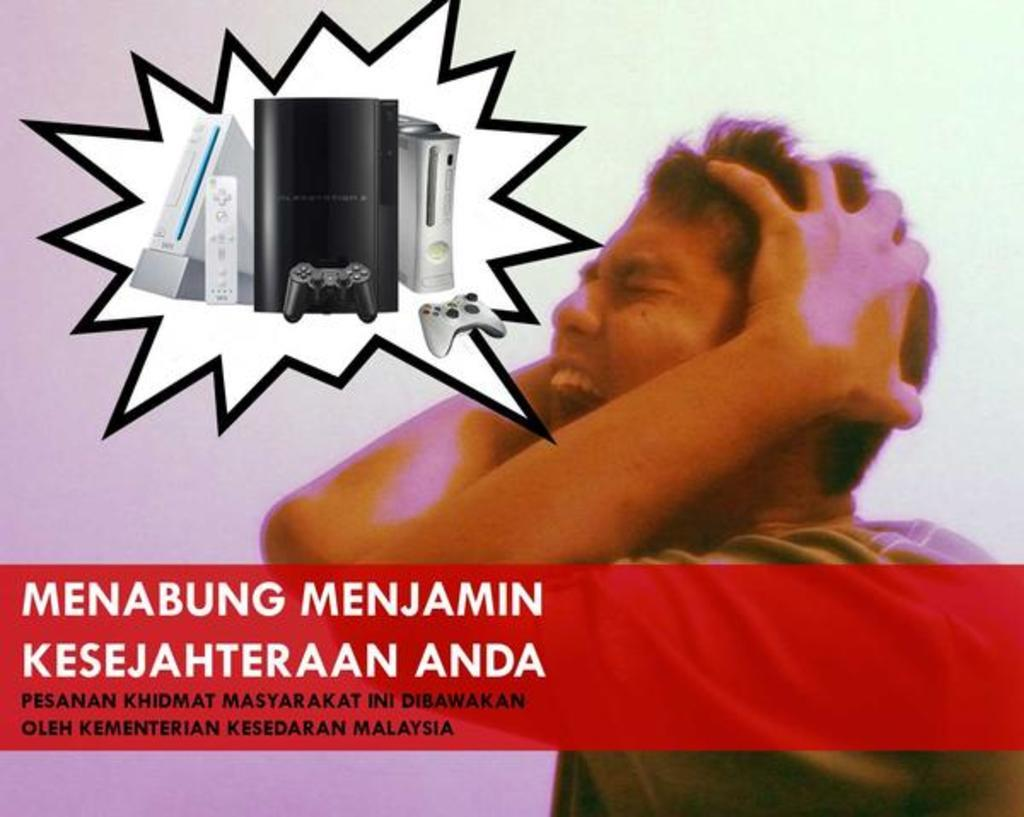Who is the main subject in the foreground of the image? There is a man in the foreground of the image. On which side of the image is the man located? The man is on the right side of the image. What can be found at the bottom of the image? There is some text at the bottom of the image. What type of objects are depicted at the top of the image? There are images of electronic devices at the top of the image. What type of linen is being used to cover the foot in the image? There is no foot or linen present in the image. What is the reason for the man's presence in the image? The image does not provide any information about the man's purpose or reason for being in the image. 